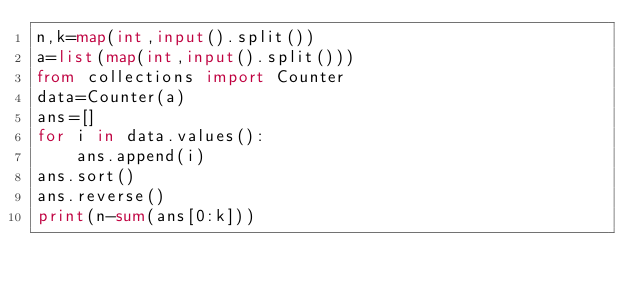<code> <loc_0><loc_0><loc_500><loc_500><_Python_>n,k=map(int,input().split())
a=list(map(int,input().split()))
from collections import Counter
data=Counter(a)
ans=[]
for i in data.values():
    ans.append(i)
ans.sort()
ans.reverse()
print(n-sum(ans[0:k]))
</code> 